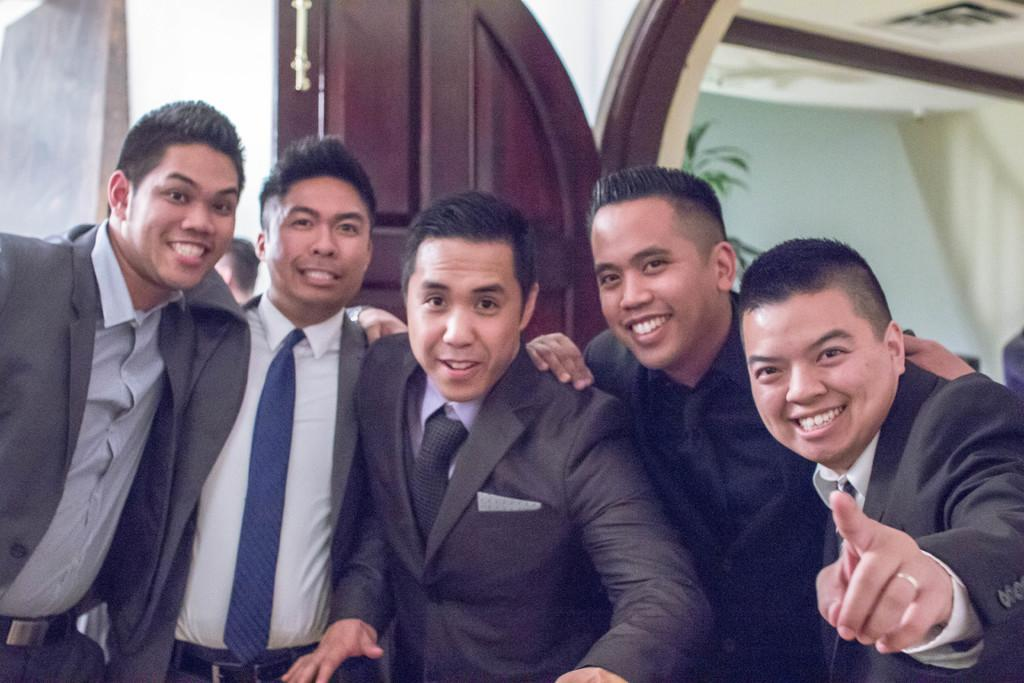What can be seen in the image? There are men standing in the image. What is visible in the background of the image? There is a door, a wall, a plant, and objects on the ceiling in the background of the image. How many bears are sitting on the plant in the image? There are no bears present in the image; it features men standing and a plant in the background. 